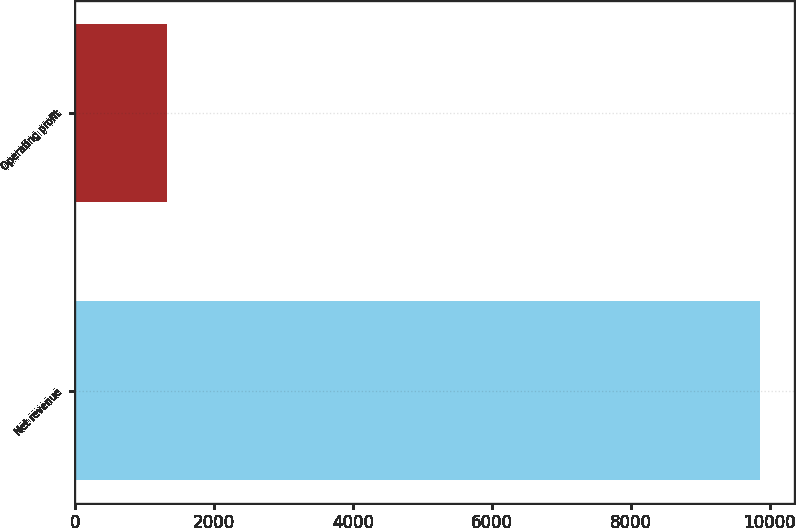<chart> <loc_0><loc_0><loc_500><loc_500><bar_chart><fcel>Net revenue<fcel>Operating profit<nl><fcel>9862<fcel>1323<nl></chart> 